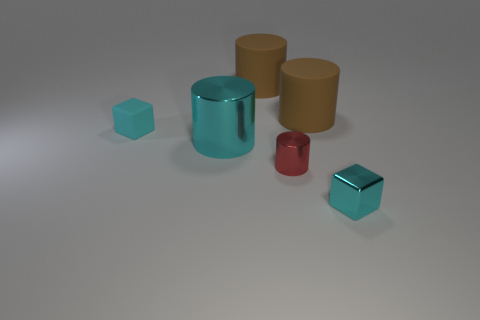Subtract all small cylinders. How many cylinders are left? 3 Subtract all cyan cylinders. How many cylinders are left? 3 Add 2 purple metal things. How many objects exist? 8 Subtract 2 cubes. How many cubes are left? 0 Subtract all blocks. How many objects are left? 4 Subtract all big brown matte cylinders. Subtract all rubber cylinders. How many objects are left? 2 Add 4 tiny red objects. How many tiny red objects are left? 5 Add 3 big shiny cylinders. How many big shiny cylinders exist? 4 Subtract 0 yellow blocks. How many objects are left? 6 Subtract all green cubes. Subtract all green cylinders. How many cubes are left? 2 